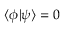Convert formula to latex. <formula><loc_0><loc_0><loc_500><loc_500>\langle \phi | \psi \rangle = 0</formula> 